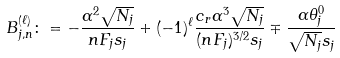Convert formula to latex. <formula><loc_0><loc_0><loc_500><loc_500>B _ { j , n } ^ { ( \ell ) } \colon = - \frac { \alpha ^ { 2 } \sqrt { N _ { j } } } { n F _ { j } s _ { j } } + ( - 1 ) ^ { \ell } \frac { c _ { r } \alpha ^ { 3 } \sqrt { N _ { j } } } { ( n F _ { j } ) ^ { 3 / 2 } s _ { j } } \mp \frac { \alpha \theta _ { j } ^ { 0 } } { \sqrt { N _ { j } } s _ { j } }</formula> 